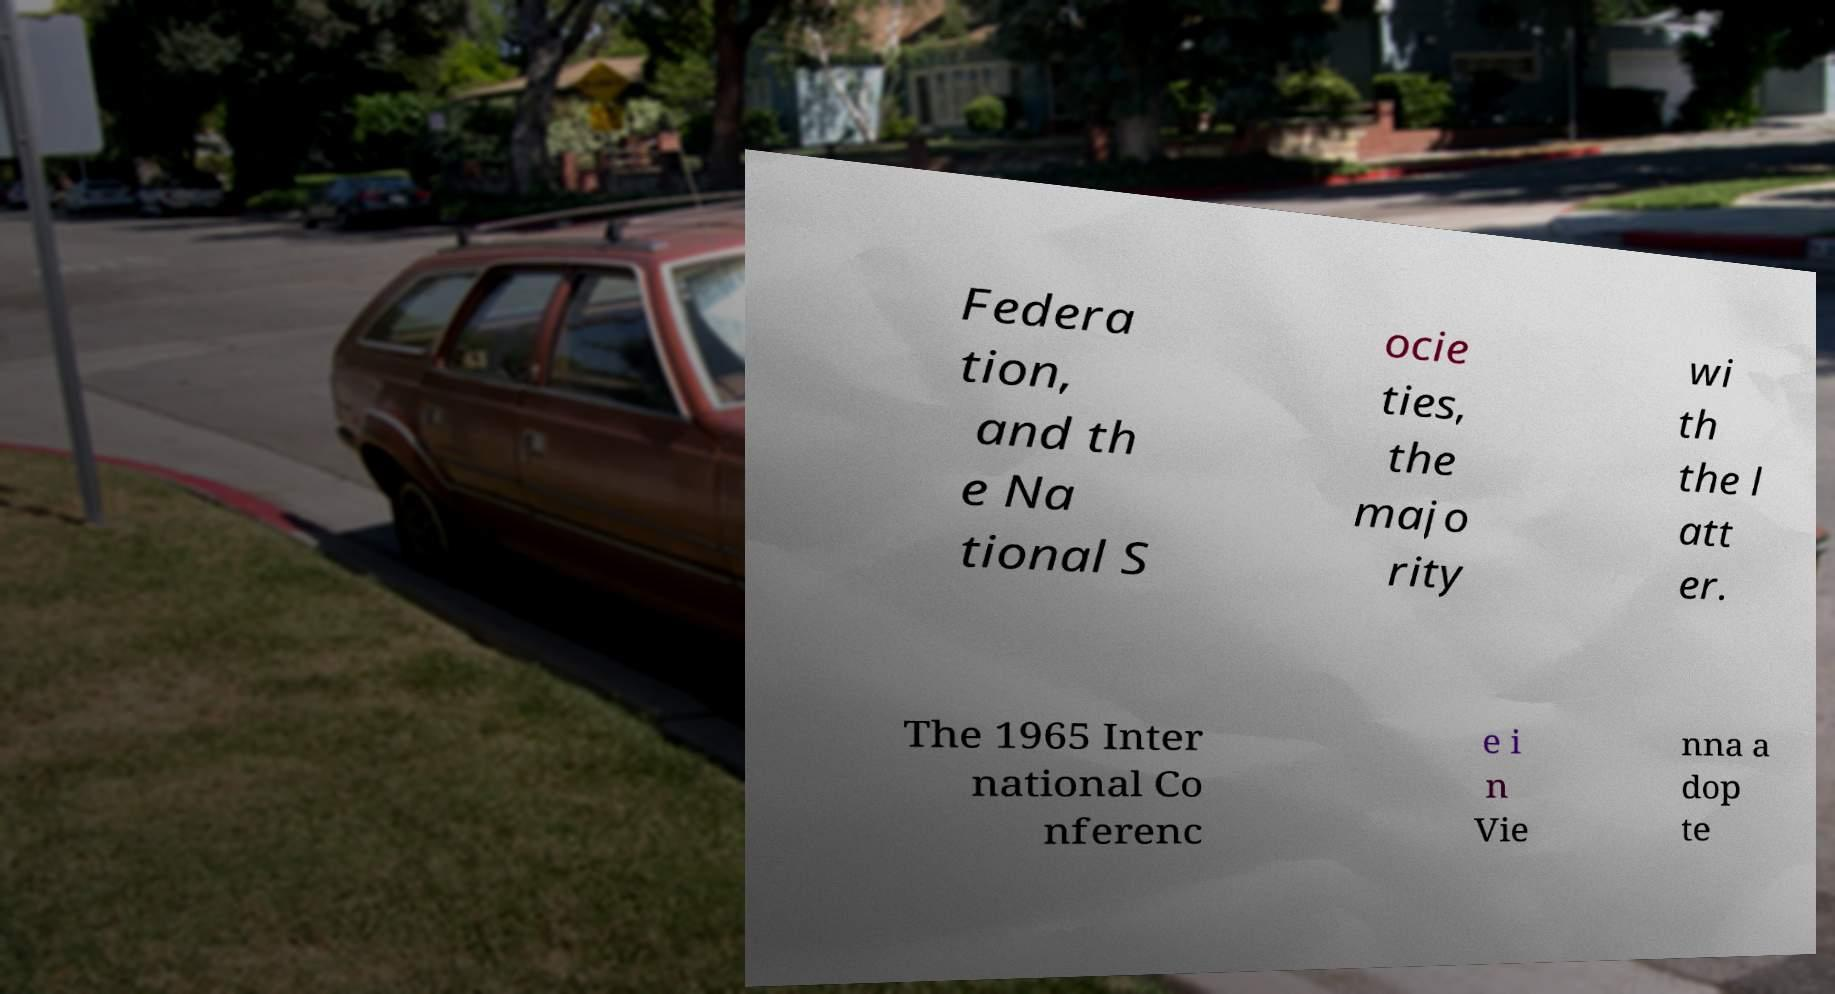What messages or text are displayed in this image? I need them in a readable, typed format. Federa tion, and th e Na tional S ocie ties, the majo rity wi th the l att er. The 1965 Inter national Co nferenc e i n Vie nna a dop te 